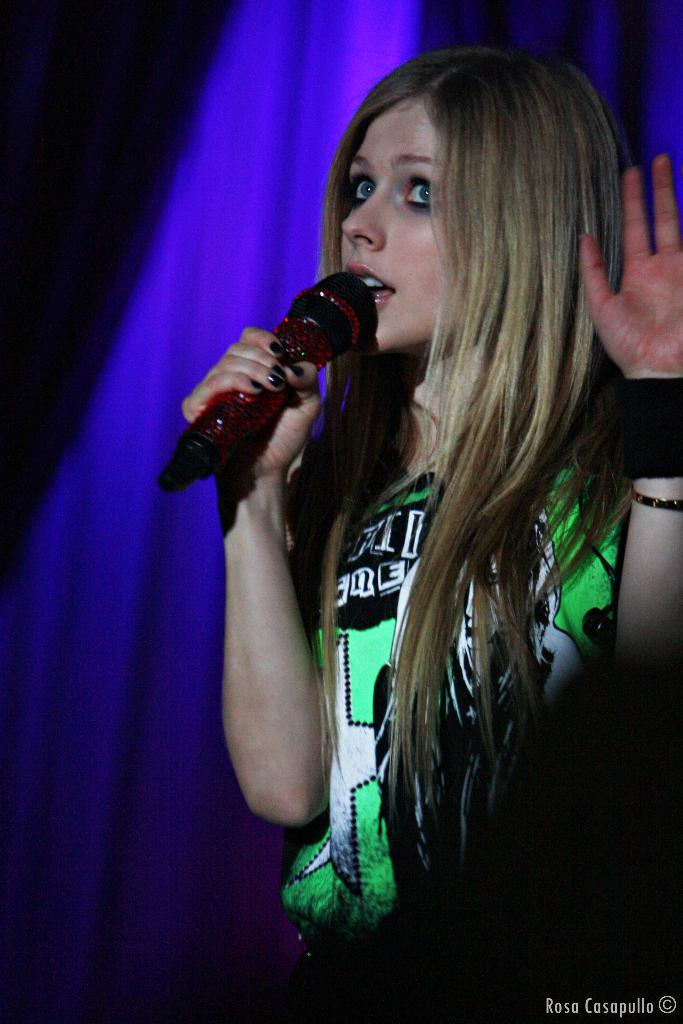Who is the main subject in the image? There is a girl in the image. What is the girl doing in the image? The girl is singing in the image. What is the girl holding while singing? She is holding a microphone in the image. Can you describe the girl's outfit? She is wearing a black and green t-shirt in the image. Are there any accessories visible on the girl? Yes, she has a bangle on her right hand and a band on her right hand. What can be seen in the background of the image? There is a blue curtain in the background of the image. How many dust particles can be seen floating around the girl in the image? There is no mention of dust particles in the image, so it is not possible to determine their number. What type of things can be seen hanging from the ceiling in the image? There is no mention of any things hanging from the ceiling in the image. 